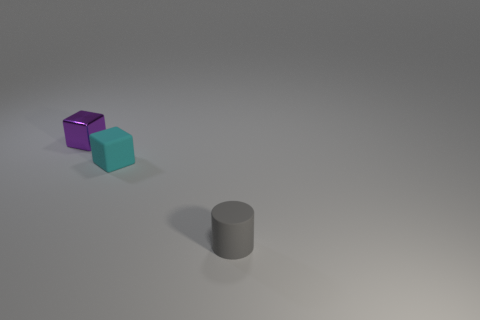Do the shiny thing and the gray object have the same shape?
Offer a very short reply. No. Is there any other thing that is the same material as the small purple cube?
Your answer should be very brief. No. What is the color of the thing that is in front of the shiny object and on the left side of the small rubber cylinder?
Your answer should be compact. Cyan. Are there more tiny gray metallic objects than gray things?
Make the answer very short. No. How many things are tiny cylinders or small things in front of the metallic cube?
Provide a succinct answer. 2. Are there any tiny blocks on the left side of the tiny rubber cube?
Ensure brevity in your answer.  Yes. How many things are either purple things or big red shiny blocks?
Make the answer very short. 1. Is there a tiny purple rubber cube?
Your answer should be very brief. No. How many objects are small blocks that are in front of the small purple metal object or tiny matte objects that are behind the cylinder?
Offer a very short reply. 1. There is a tiny cube on the right side of the small metallic thing; how many blocks are in front of it?
Make the answer very short. 0. 